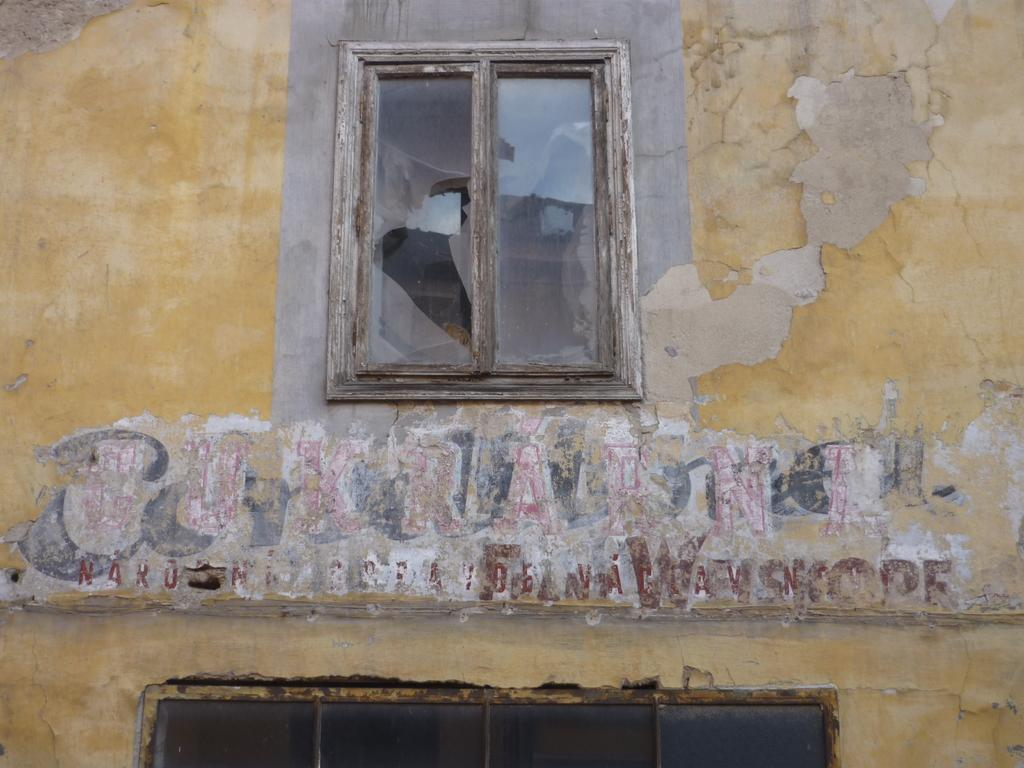What is the main feature in the center of the image? There is a window in the center of the image. What can be seen on the wall of a building in the image? There is text on the wall of a building in the image. What else is visible in the foreground of the image? There are other objects visible in the foreground of the image. How many geese are flying in the image? There are no geese visible in the image. What type of hammer is being used by the police officer in the image? There are no police officers or hammers present in the image. 